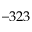<formula> <loc_0><loc_0><loc_500><loc_500>- 3 2 3</formula> 